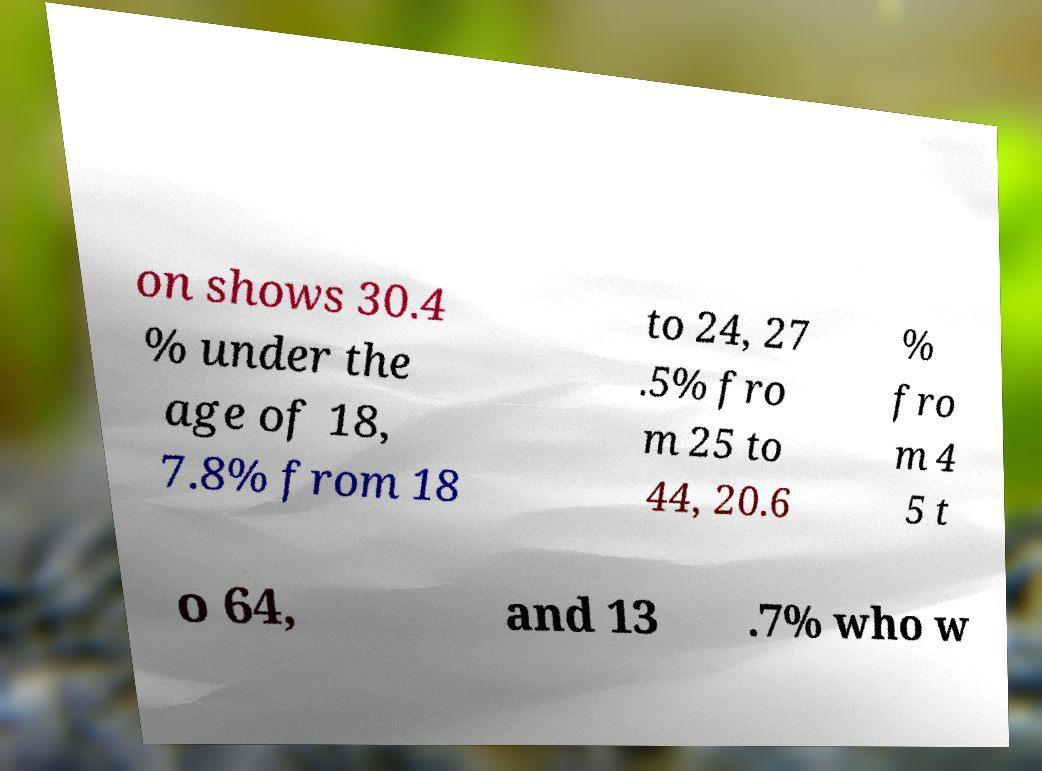Can you accurately transcribe the text from the provided image for me? on shows 30.4 % under the age of 18, 7.8% from 18 to 24, 27 .5% fro m 25 to 44, 20.6 % fro m 4 5 t o 64, and 13 .7% who w 